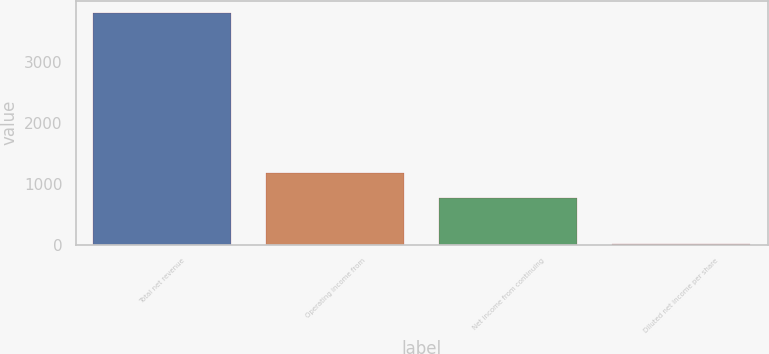Convert chart to OTSL. <chart><loc_0><loc_0><loc_500><loc_500><bar_chart><fcel>Total net revenue<fcel>Operating income from<fcel>Net income from continuing<fcel>Diluted net income per share<nl><fcel>3808<fcel>1168<fcel>764<fcel>2.51<nl></chart> 